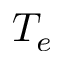Convert formula to latex. <formula><loc_0><loc_0><loc_500><loc_500>T _ { e }</formula> 